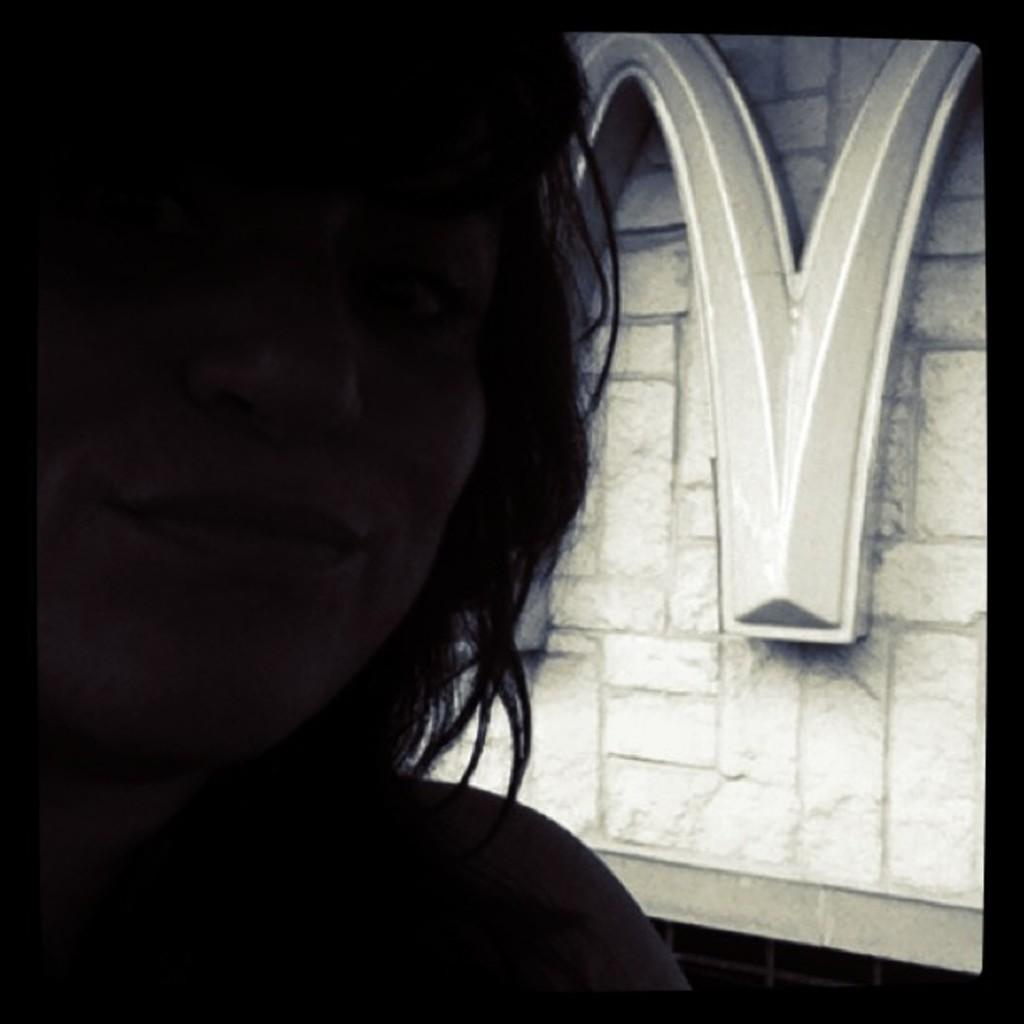What is the main subject of the image? There is a person's face in the image. What can be seen in the background of the image? There is a wall with a design in the background of the image. What type of yarn is the person using to cry in the image? There is no yarn or crying depicted in the image; it only features a person's face and a wall with a design in the background. 